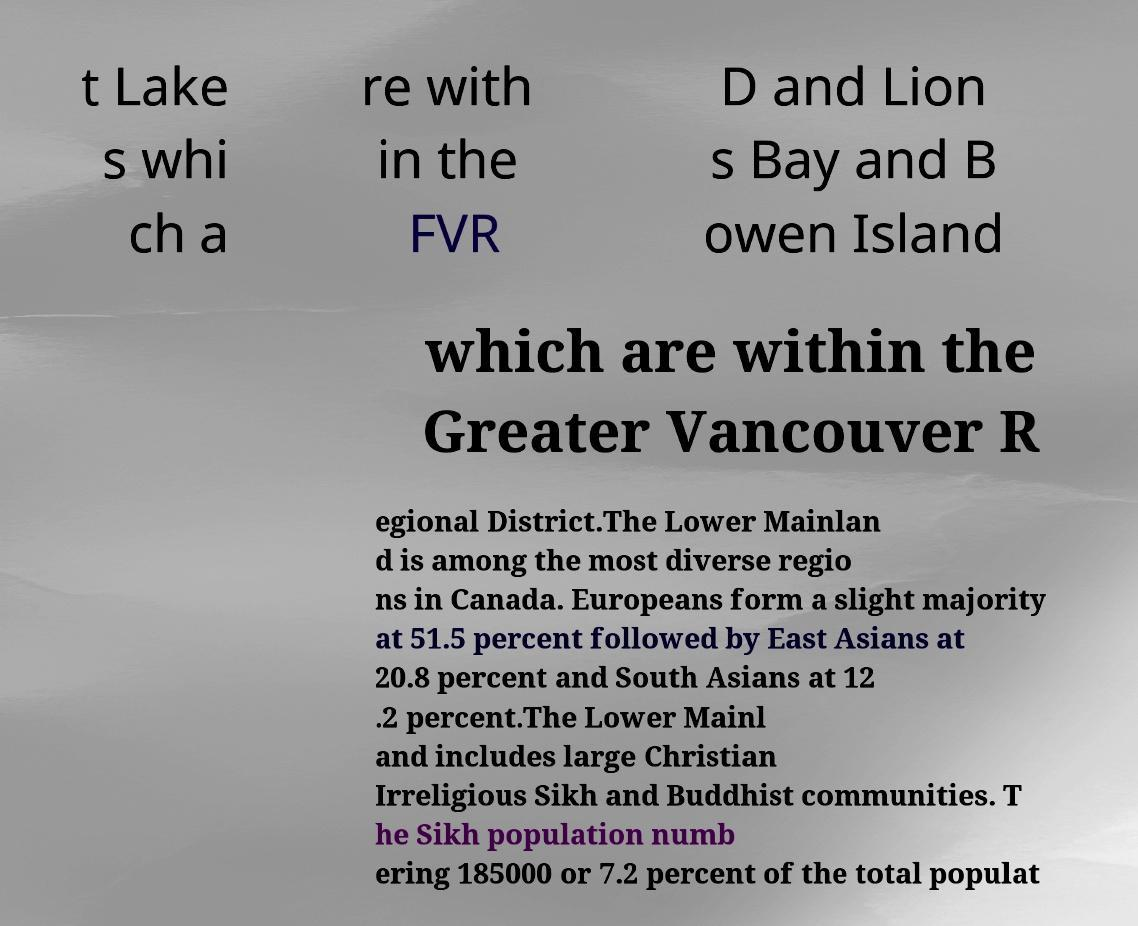For documentation purposes, I need the text within this image transcribed. Could you provide that? t Lake s whi ch a re with in the FVR D and Lion s Bay and B owen Island which are within the Greater Vancouver R egional District.The Lower Mainlan d is among the most diverse regio ns in Canada. Europeans form a slight majority at 51.5 percent followed by East Asians at 20.8 percent and South Asians at 12 .2 percent.The Lower Mainl and includes large Christian Irreligious Sikh and Buddhist communities. T he Sikh population numb ering 185000 or 7.2 percent of the total populat 